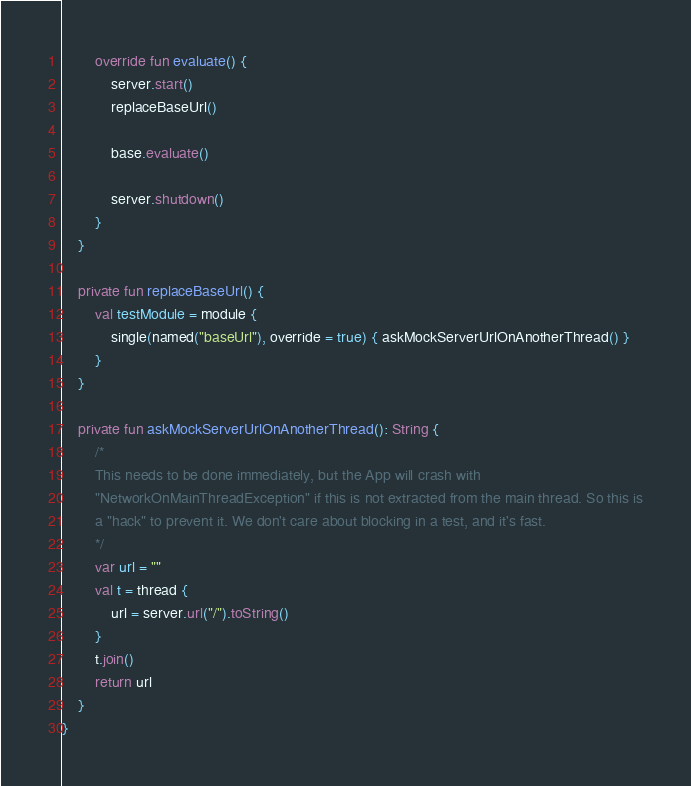<code> <loc_0><loc_0><loc_500><loc_500><_Kotlin_>        override fun evaluate() {
            server.start()
            replaceBaseUrl()

            base.evaluate()

            server.shutdown()
        }
    }

    private fun replaceBaseUrl() {
        val testModule = module {
            single(named("baseUrl"), override = true) { askMockServerUrlOnAnotherThread() }
        }
    }

    private fun askMockServerUrlOnAnotherThread(): String {
        /*
        This needs to be done immediately, but the App will crash with
        "NetworkOnMainThreadException" if this is not extracted from the main thread. So this is
        a "hack" to prevent it. We don't care about blocking in a test, and it's fast.
        */
        var url = ""
        val t = thread {
            url = server.url("/").toString()
        }
        t.join()
        return url
    }
}</code> 